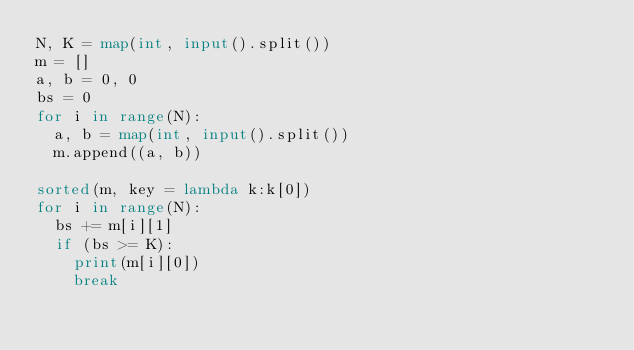Convert code to text. <code><loc_0><loc_0><loc_500><loc_500><_Python_>N, K = map(int, input().split())
m = []
a, b = 0, 0
bs = 0
for i in range(N):
  a, b = map(int, input().split())
  m.append((a, b))

sorted(m, key = lambda k:k[0])
for i in range(N):
  bs += m[i][1]
  if (bs >= K):
    print(m[i][0])
    break
</code> 